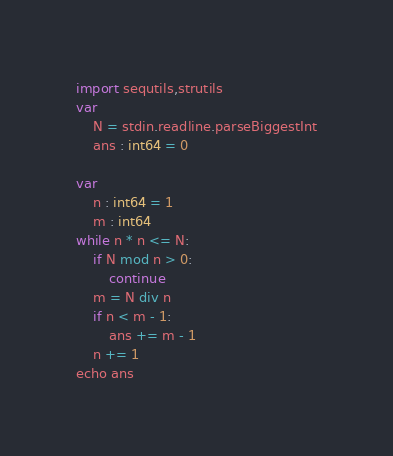<code> <loc_0><loc_0><loc_500><loc_500><_Nim_>import sequtils,strutils
var
    N = stdin.readline.parseBiggestInt
    ans : int64 = 0

var
    n : int64 = 1
    m : int64
while n * n <= N:
    if N mod n > 0:
        continue
    m = N div n
    if n < m - 1:
        ans += m - 1
    n += 1
echo ans</code> 